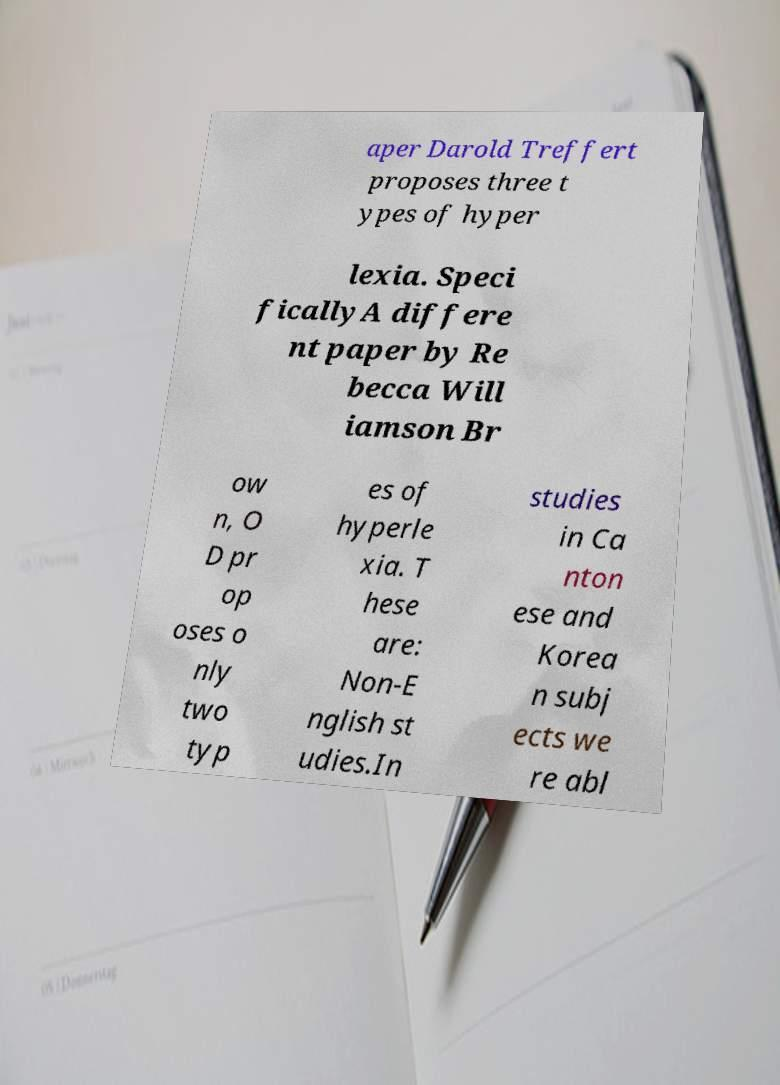I need the written content from this picture converted into text. Can you do that? aper Darold Treffert proposes three t ypes of hyper lexia. Speci ficallyA differe nt paper by Re becca Will iamson Br ow n, O D pr op oses o nly two typ es of hyperle xia. T hese are: Non-E nglish st udies.In studies in Ca nton ese and Korea n subj ects we re abl 